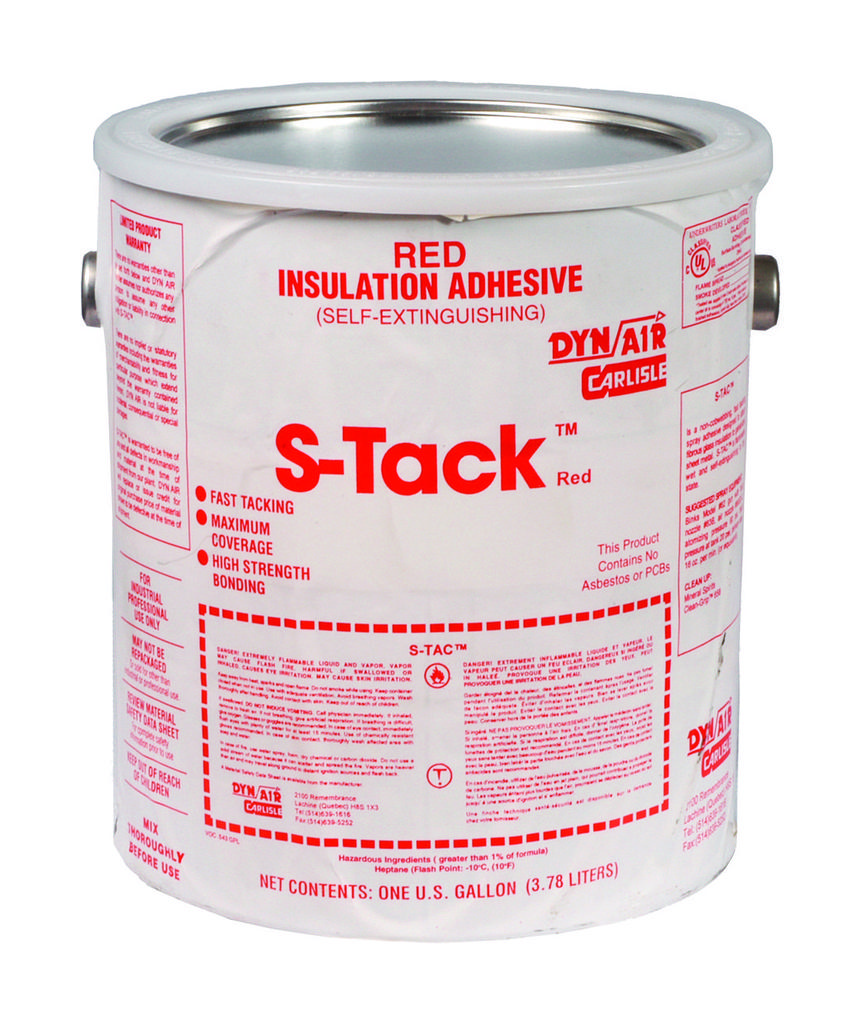What is the main object in the image? There is a white box in the image. What color is the background of the image? The background of the image is white. What type of curtain is hanging in front of the white box in the image? There is no curtain present in the image. What grade does the white box receive in the image? The image does not depict a grading system or any evaluation of the white box. 